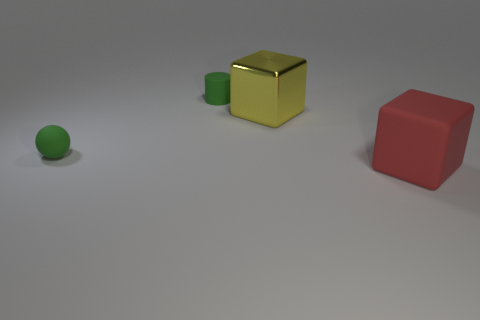Add 3 small green things. How many objects exist? 7 Subtract all cylinders. How many objects are left? 3 Subtract all green rubber objects. Subtract all large red cubes. How many objects are left? 1 Add 4 yellow metallic things. How many yellow metallic things are left? 5 Add 2 tiny red metal objects. How many tiny red metal objects exist? 2 Subtract 0 blue cubes. How many objects are left? 4 